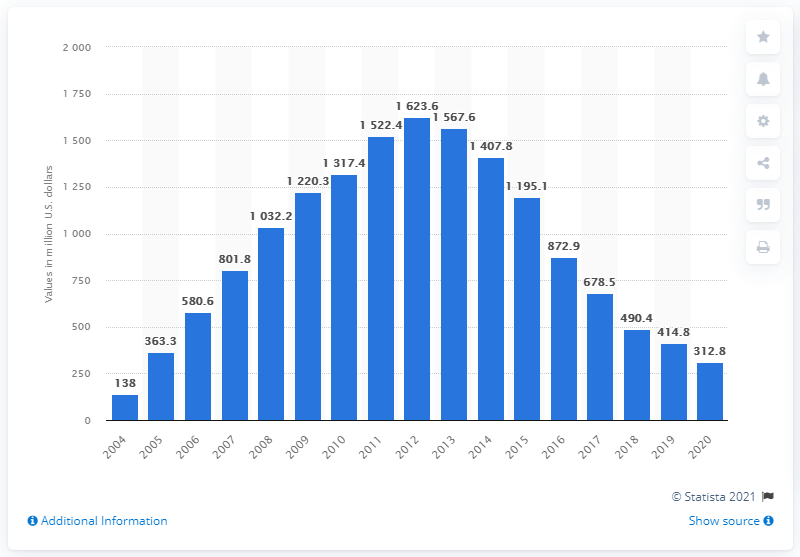List a handful of essential elements in this visual. The retail value of digital single downloads between 2004 and 2020 was approximately 312.8 billion dollars. 